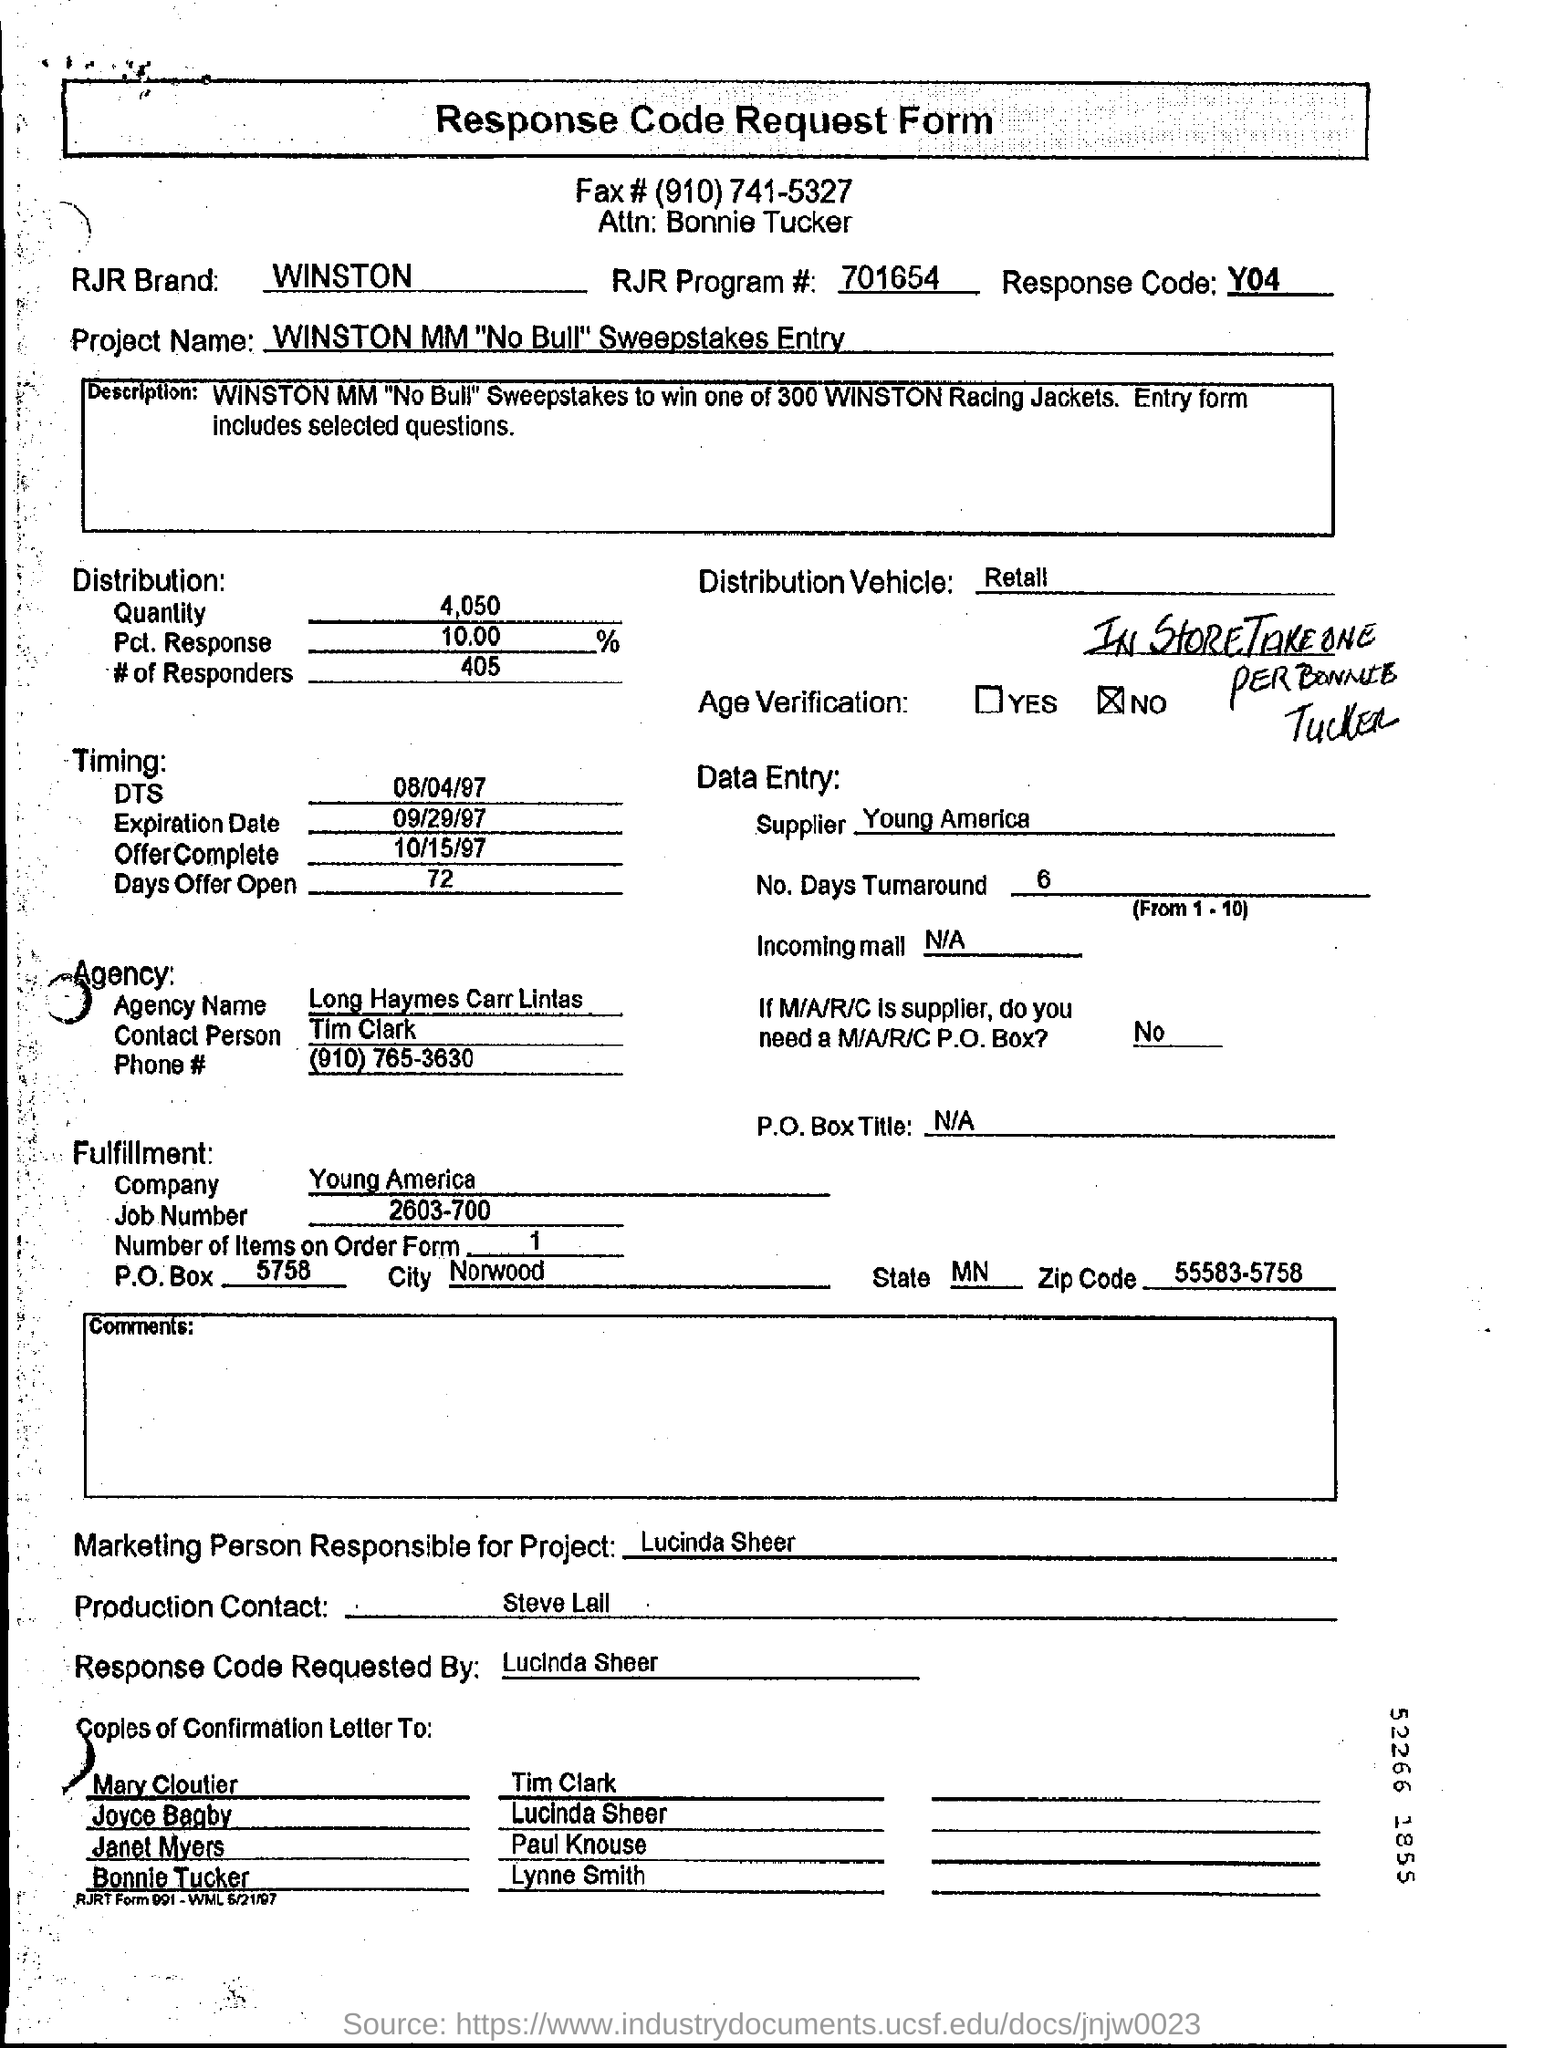What is the RJR Brand?
Make the answer very short. Winston. What is the Fax#?
Your response must be concise. (910) 741-5327. What is the Response code?
Make the answer very short. Y04. Who is the Attn: to?
Provide a short and direct response. Bonnie Tucker. What is the Quantity?
Provide a short and direct response. 4,050. What is the Pct. Response?
Offer a very short reply. 10.00%. What is the # of responders?
Provide a succinct answer. 405. What is the distribution vehicle?
Your response must be concise. Retail. Who is the marketing person responsible for the project?
Provide a succinct answer. Lucinda Sheer. Who is the Production contact?
Provide a succinct answer. Steve Lall. 